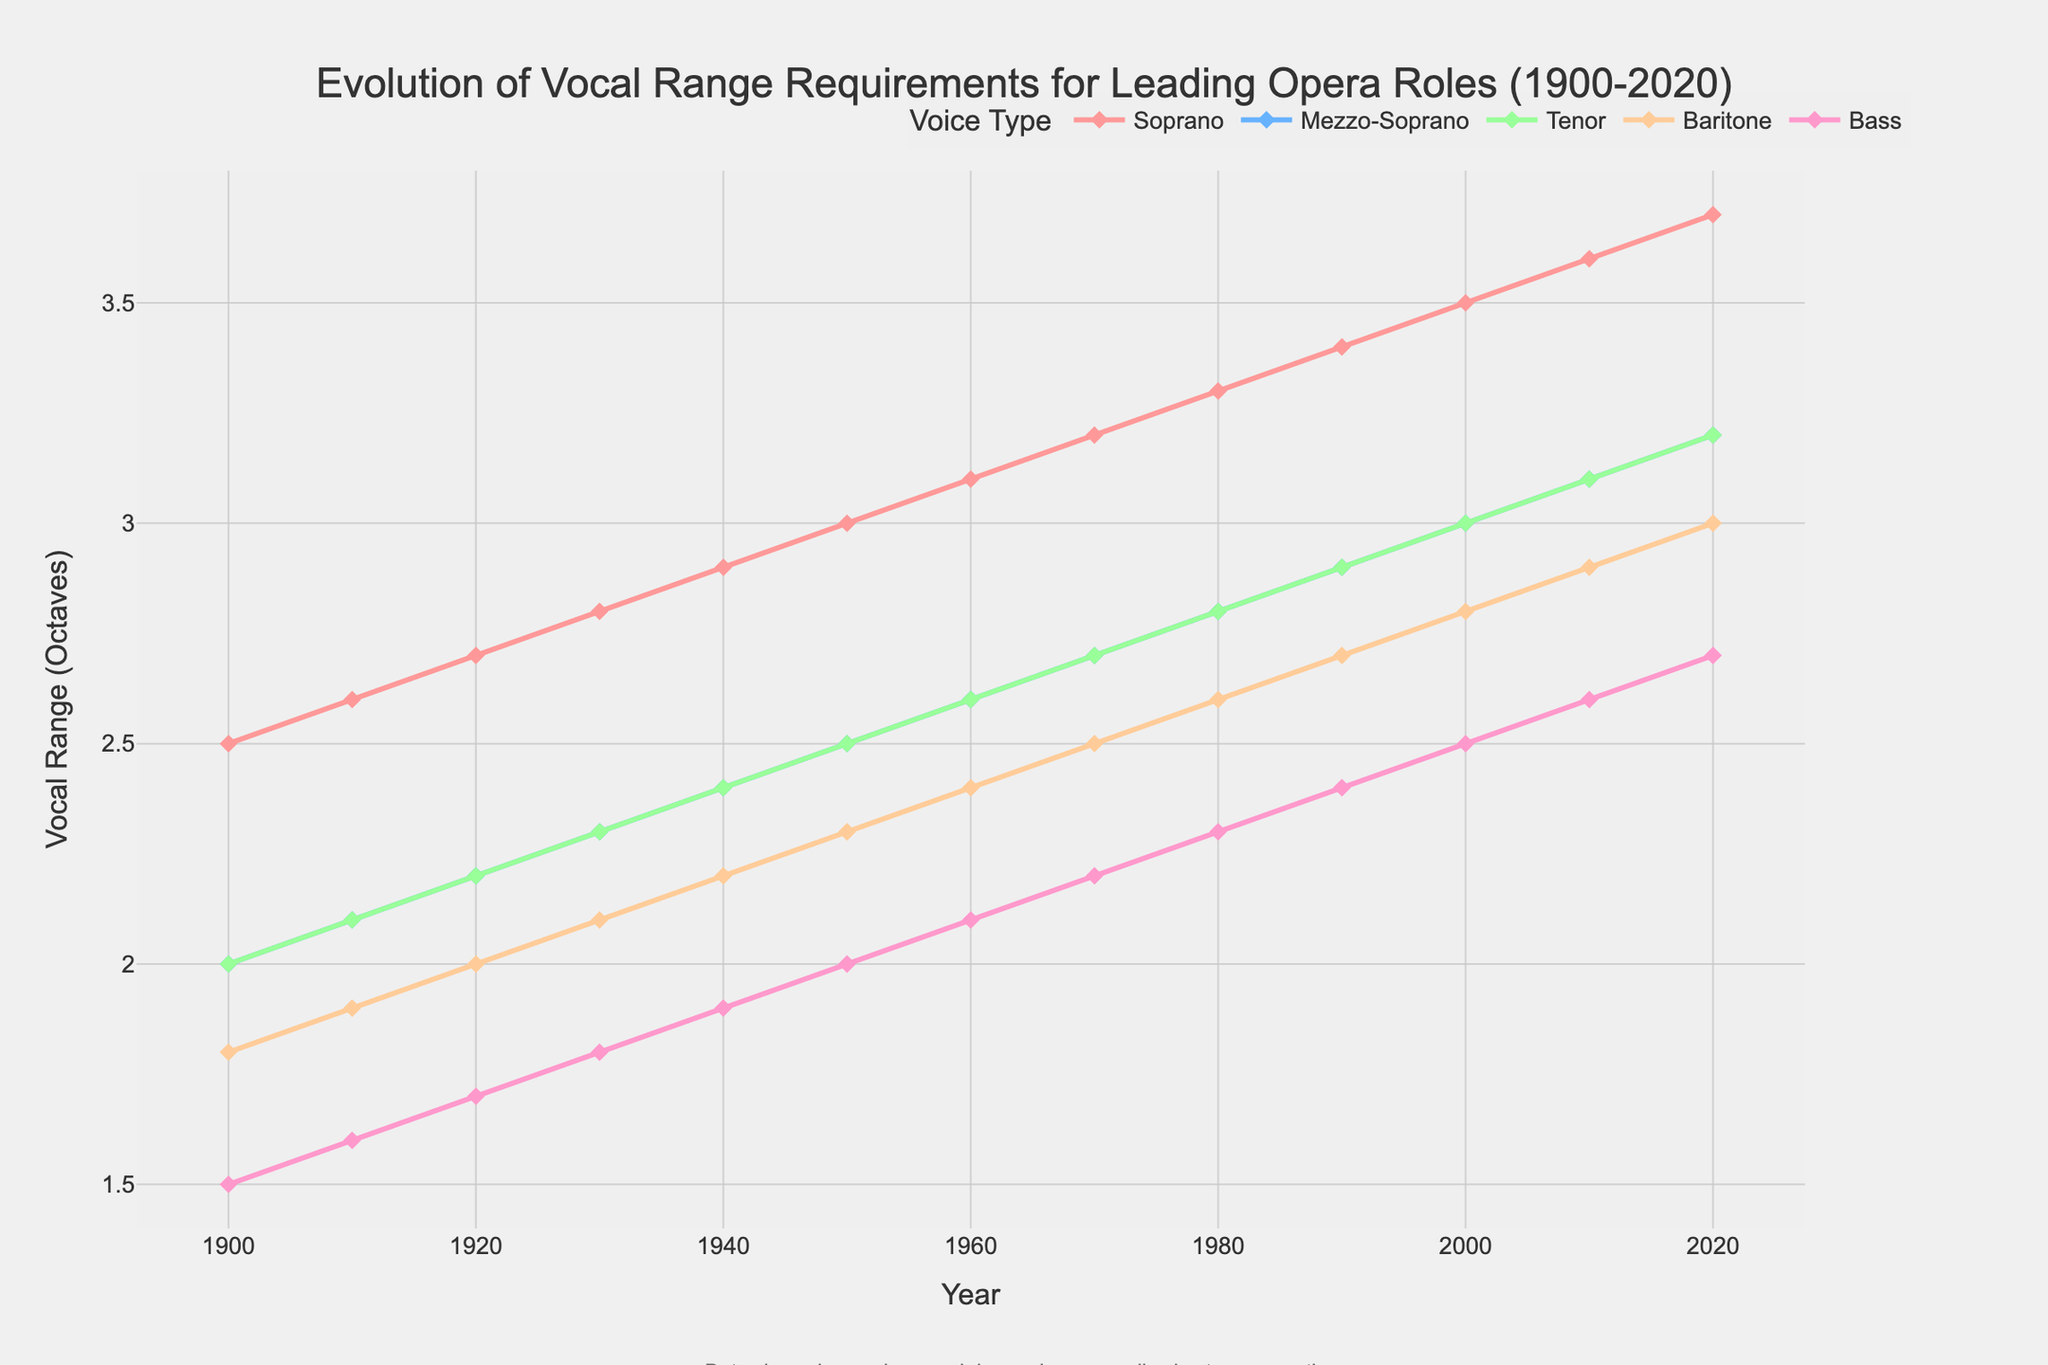What's the vocal range for Sopranos in 2020? Look at the line for Sopranos and find the data point for the year 2020. The vocal range is shown at the intersection.
Answer: 3.7 octaves Which voice type shows the greatest increase in vocal range from 1900 to 2020? Calculate the difference between the 2020 and 1900 values for each voice type. Soprano: (3.7 - 2.5) = 1.2, Mezzo-Soprano: (3.2 - 2.0) = 1.2, Tenor: (3.2 - 2.0) = 1.2, Baritone: (3.0 - 1.8) = 1.2, Bass: (2.7 - 1.5) = 1.2. They all share the same increase.
Answer: Soprano, Mezzo-Soprano, Tenor, Baritone, Bass In what decade did the Soprano vocal range surpass 3.5 octaves? Track the Soprano line and identify the first decade where the data point is greater than 3.5. This happens in the 2000s.
Answer: 2000s How does the vocal range for Bass compare to Baritone in 1980? Check the data points for both Bass and Baritone in 1980. Baritone is at 2.6 octaves, while Bass is at 2.3 octaves. Baritone has a greater range.
Answer: Baritone > Bass Arrange the vocal range requirements in 1900 from lowest to highest. Examine the values in 1900: Bass (1.5), Baritone (1.8), Mezzo-Soprano (2.0), Tenor (2.0), Soprano (2.5). Listing them in order gives us Bass, Baritone, Mezzo-Soprano, Tenor, Soprano.
Answer: Bass, Baritone, Mezzo-Soprano, Tenor, Soprano What is the combined total vocal range of Mezzo-Sopranos and Tenors in 1950? Find ranges for Mezzo-Sopranos (2.5) and Tenors (2.5) in 1950, then add them: 2.5 + 2.5 = 5.0 octaves.
Answer: 5.0 octaves Which decade saw the smallest increment in vocal range requirements for Tenors between two consecutive decades? Determine the difference for each decade: 1910 (0.1), 1920 (0.1), 1930 (0.1), 1940 (0.1), 1950 (0.1), 1960 (0.1), 1970 (0.1), 1980 (0.1), 1990 (0.1), 2000 (0.1), 2010 (0.1), 2020 (0.1). All increments are identical.
Answer: All are equal What’s the average vocal range across all voice types in 2010? Add ranges from 2010: Soprano (3.6), Mezzo-Soprano (3.1), Tenor (3.1), Baritone (2.9), Bass (2.6). The total is 15.3. Divide by 5 (number of voice types): 15.3 / 5 = 3.06 octaves.
Answer: 3.06 octaves 